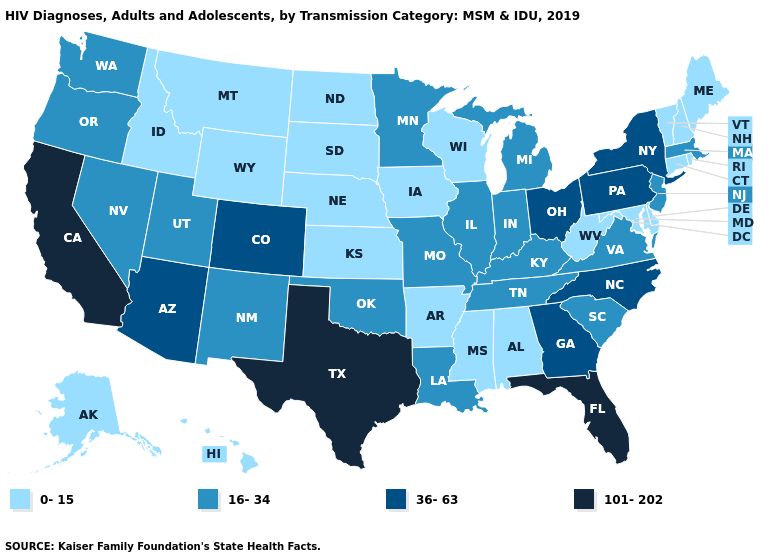What is the value of Vermont?
Keep it brief. 0-15. Does Montana have the lowest value in the West?
Answer briefly. Yes. What is the value of Montana?
Write a very short answer. 0-15. What is the value of Indiana?
Be succinct. 16-34. What is the value of Washington?
Answer briefly. 16-34. Does the first symbol in the legend represent the smallest category?
Keep it brief. Yes. What is the highest value in states that border Delaware?
Concise answer only. 36-63. Does South Dakota have the highest value in the USA?
Short answer required. No. Does California have the highest value in the USA?
Write a very short answer. Yes. What is the lowest value in the MidWest?
Concise answer only. 0-15. Does Minnesota have a higher value than Texas?
Give a very brief answer. No. Is the legend a continuous bar?
Concise answer only. No. Does the first symbol in the legend represent the smallest category?
Be succinct. Yes. Which states have the lowest value in the USA?
Give a very brief answer. Alabama, Alaska, Arkansas, Connecticut, Delaware, Hawaii, Idaho, Iowa, Kansas, Maine, Maryland, Mississippi, Montana, Nebraska, New Hampshire, North Dakota, Rhode Island, South Dakota, Vermont, West Virginia, Wisconsin, Wyoming. Among the states that border Arkansas , which have the lowest value?
Answer briefly. Mississippi. 